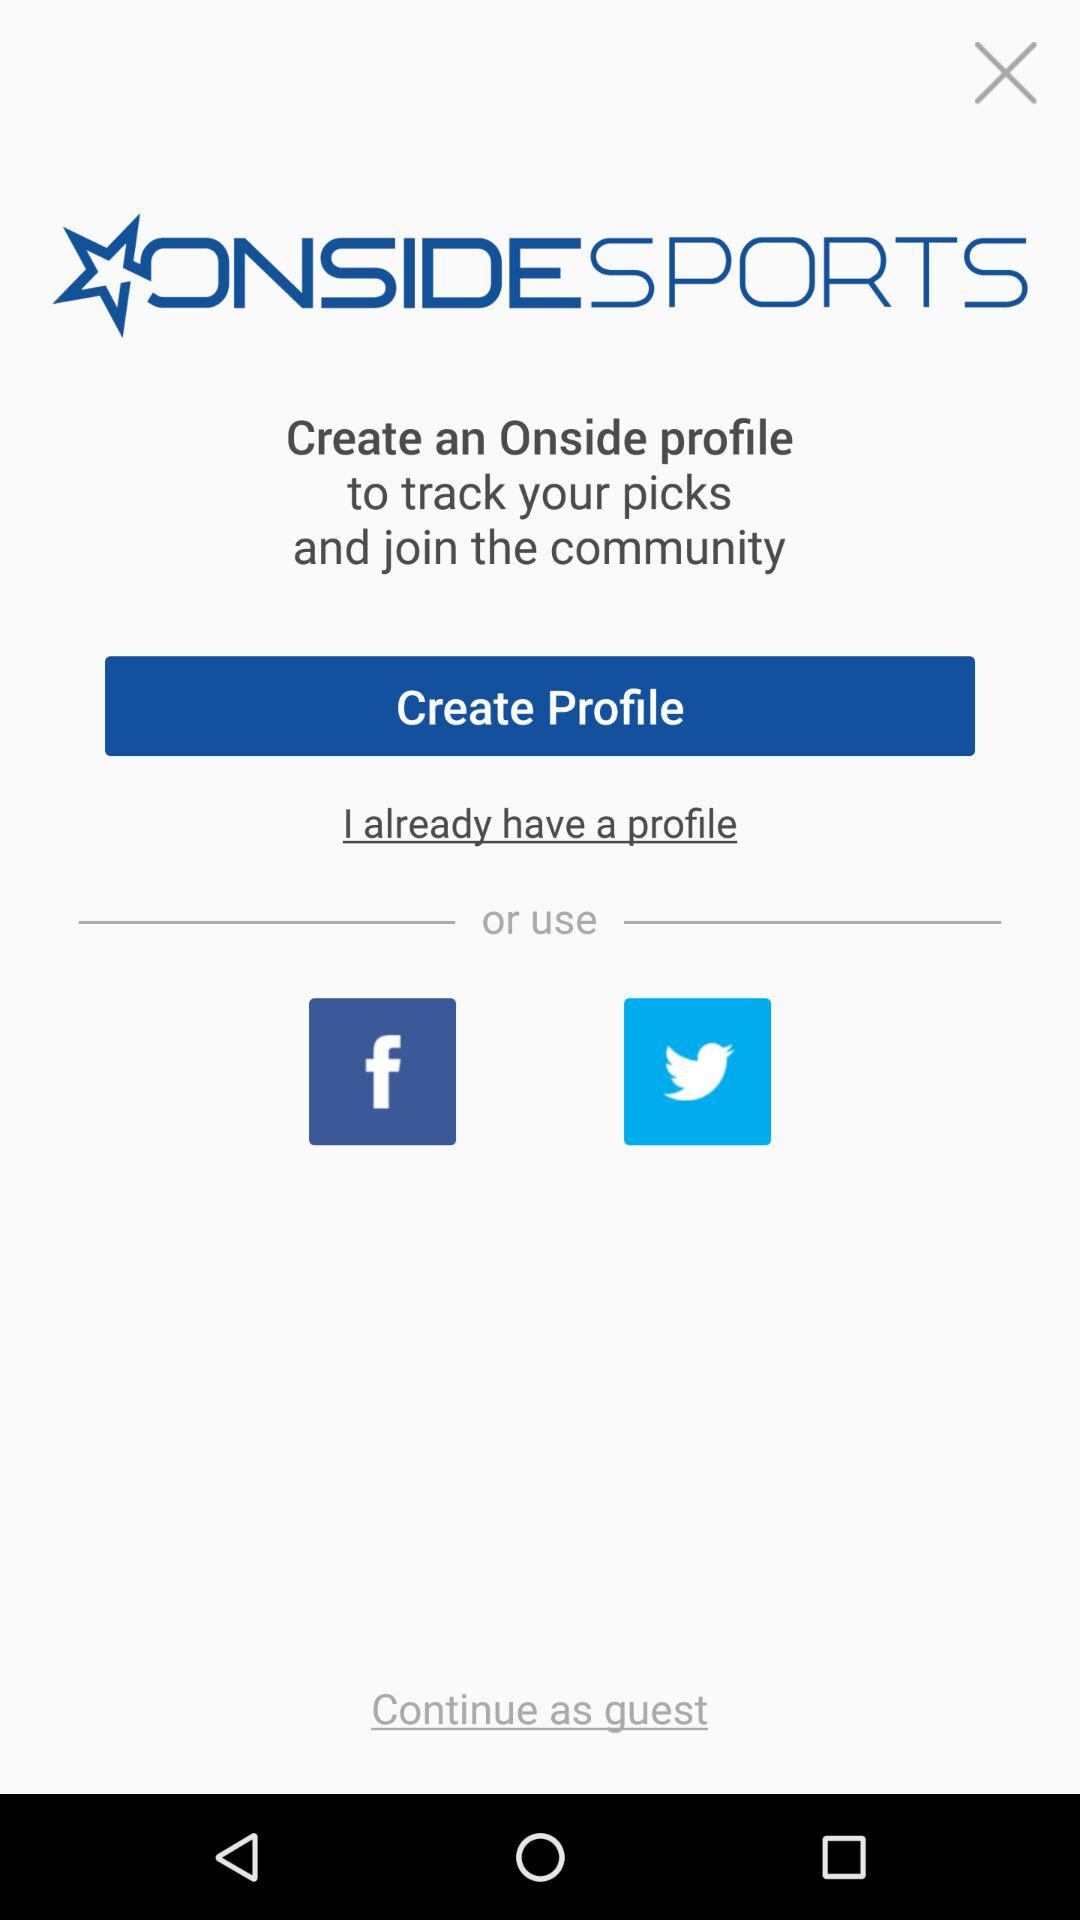What is the application name? The application name is "ONSIDESPORTS". 